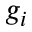<formula> <loc_0><loc_0><loc_500><loc_500>g _ { i }</formula> 